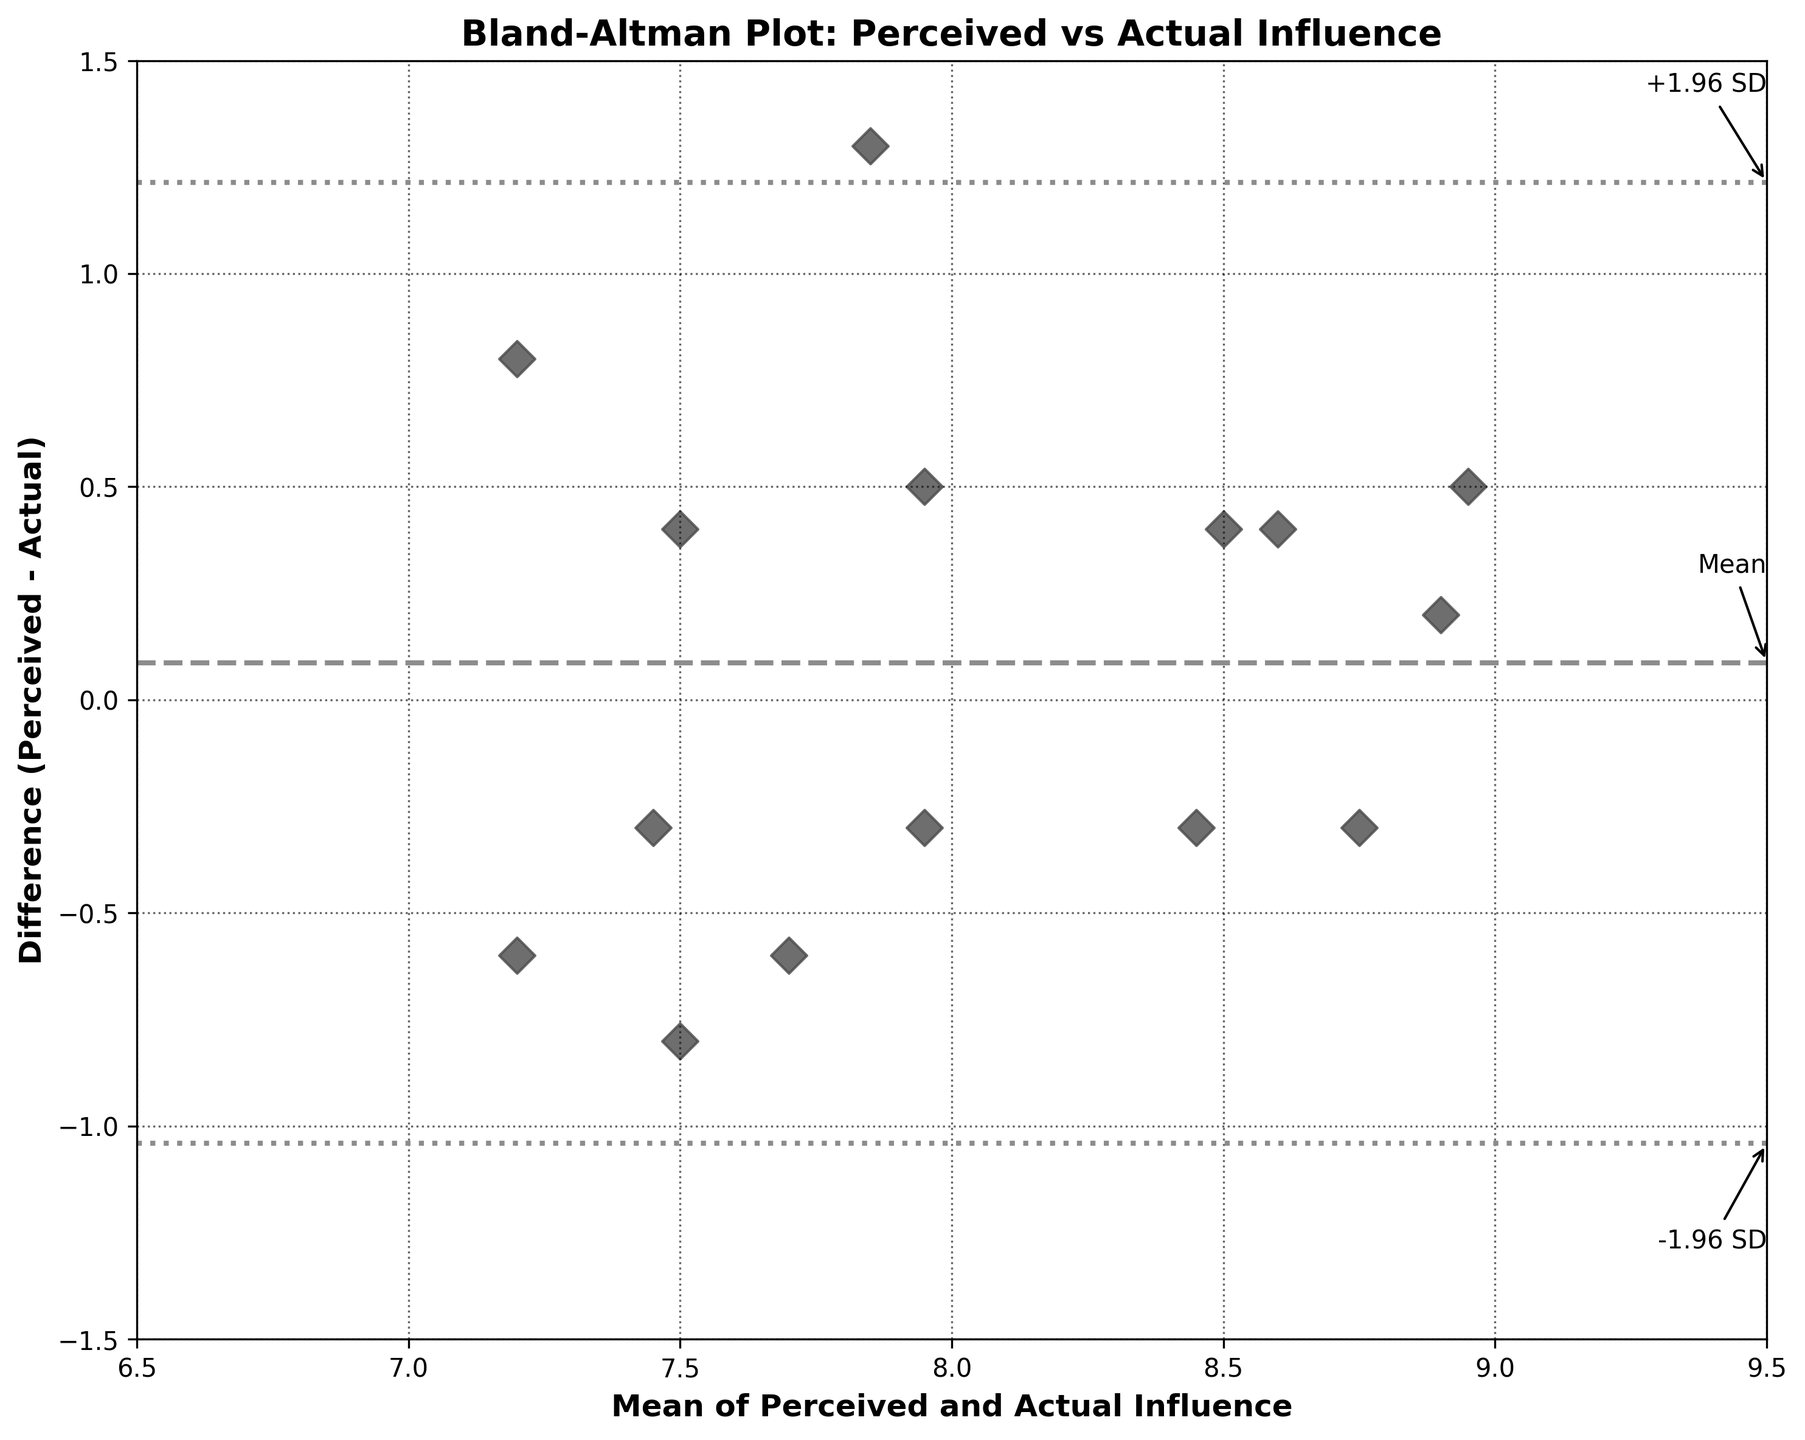What is the title of the plot? The title is typically found at the top of the figure and provides a summary of what the chart is about. In this case, the title is 'Bland-Altman Plot: Perceived vs Actual Influence'.
Answer: Bland-Altman Plot: Perceived vs Actual Influence What are the labels on the x-axis and y-axis? The axis labels describe what each axis represents. Here, the x-axis is labeled 'Mean of Perceived and Actual Influence', and the y-axis is labeled 'Difference (Perceived - Actual)'.
Answer: Mean of Perceived and Actual Influence, Difference (Perceived - Actual) How many data points are plotted? The data points can be identified by counting the individual markers on the graph. Each marker represents a unique set of values. There are 15 data points as there are 15 coach-team member pairs in the provided dataset.
Answer: 15 What does the dashed horizontal line represent in the plot? The dashed line in the plot represents the mean of the differences between perceived and actual influence. This is a standard feature of Bland-Altman plots to show overall bias.
Answer: Mean difference What do the dotted lines indicate in the plot? The dotted lines indicate the limits of agreement, which are the mean difference plus and minus 1.96 times the standard deviation of the differences. These lines show the range within which most differences between perceived and actual influence are likely to fall.
Answer: Limits of agreement What's the average of the mean of perceived and actual influence values plotted along the x-axis? To find this, sum up all mean values of perceived and actual influence and divide by the number of data points.
Answer: 8 Which coach-team member pair has the highest mean influence? Find the highest value along the x-axis where the mean of perceived and actual influence values are plotted. The marker with the highest x-value corresponds to Lisa Chen and Carlos Mendoza with a mean of 8.95.
Answer: Lisa Chen and Carlos Mendoza Which data point has the greatest positive difference between perceived and actual influence? The data point with the highest positive value along the y-axis indicates the greatest positive difference. This corresponds to Sarah Johnson and Alex Rodriguez with a difference of 1.3.
Answer: Sarah Johnson and Alex Rodriguez Which data point has the greatest negative difference between perceived and actual influence? The data point with the lowest (most negative) value along the y-axis indicates the greatest negative difference. This corresponds to Jennifer Davis and Ethan Nguyen with a difference of 0.8.
Answer: Jennifer Davis and Ethan Nguyen Are there more data points above or below the mean difference line? Count the number of data points above and below the horizontal dashed line representing the mean difference. If data points are more frequent above the line, that suggests a positive overall bias, and vice versa. Here, there are 7 points above and 8 points below.
Answer: Below 